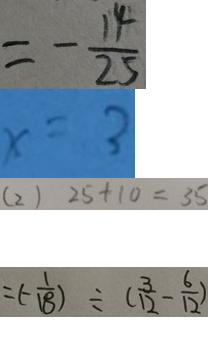Convert formula to latex. <formula><loc_0><loc_0><loc_500><loc_500>= - \frac { 1 4 } { 2 5 } 
 x = 3 
 ( 2 ) 2 5 + 1 0 = 3 5 
 = ( - \frac { 1 } { 1 8 } ) \div ( \frac { 3 } { 1 2 } - \frac { 6 } { 1 2 } )</formula> 